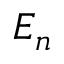Convert formula to latex. <formula><loc_0><loc_0><loc_500><loc_500>E _ { n }</formula> 